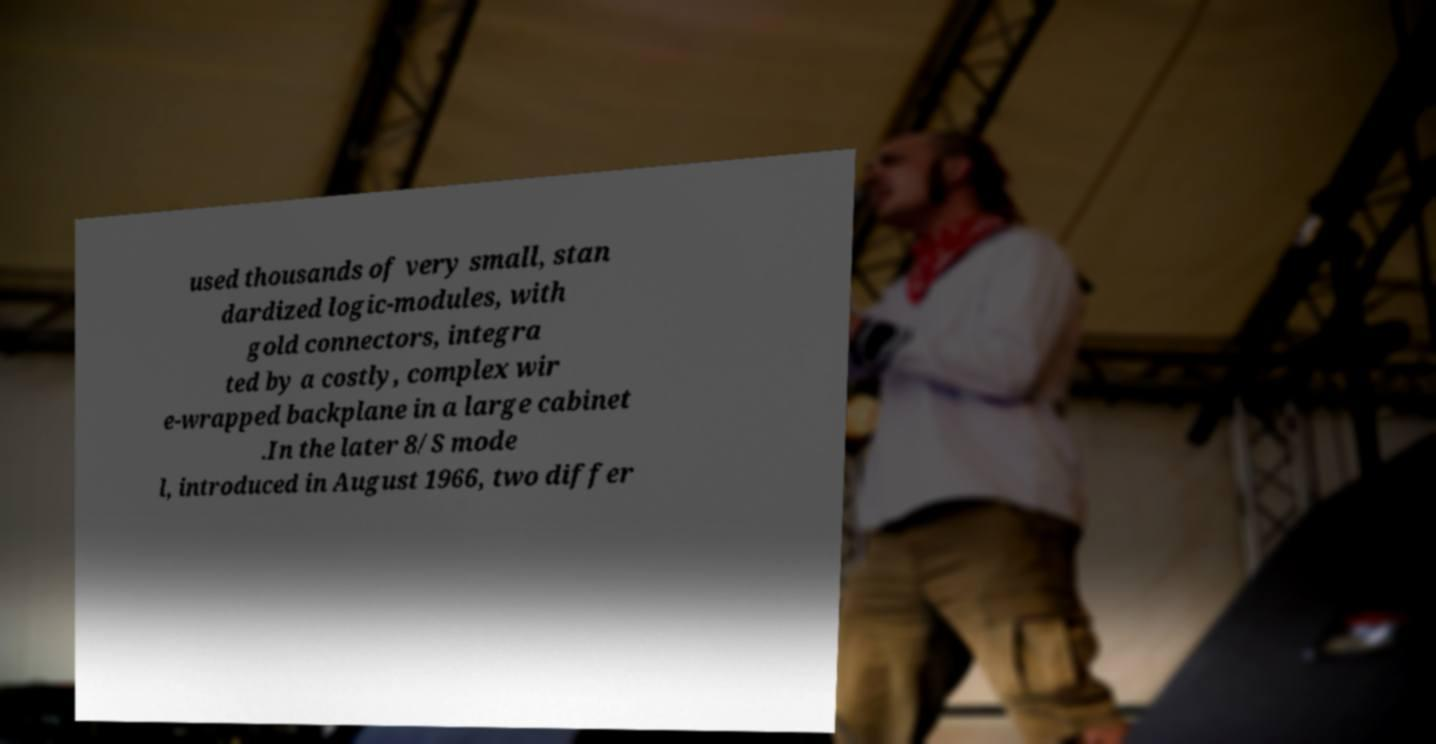Can you accurately transcribe the text from the provided image for me? used thousands of very small, stan dardized logic-modules, with gold connectors, integra ted by a costly, complex wir e-wrapped backplane in a large cabinet .In the later 8/S mode l, introduced in August 1966, two differ 